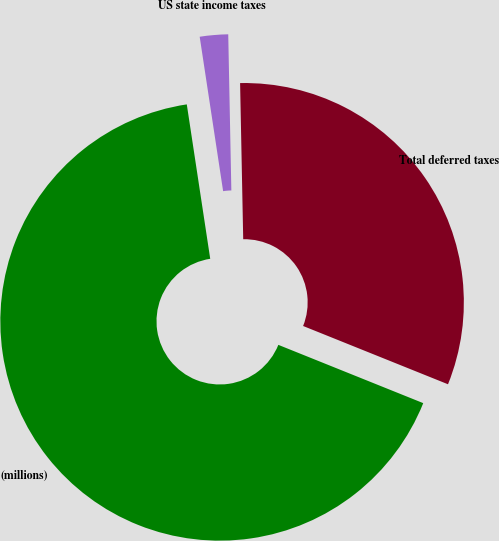Convert chart to OTSL. <chart><loc_0><loc_0><loc_500><loc_500><pie_chart><fcel>(millions)<fcel>US state income taxes<fcel>Total deferred taxes<nl><fcel>66.51%<fcel>2.08%<fcel>31.4%<nl></chart> 